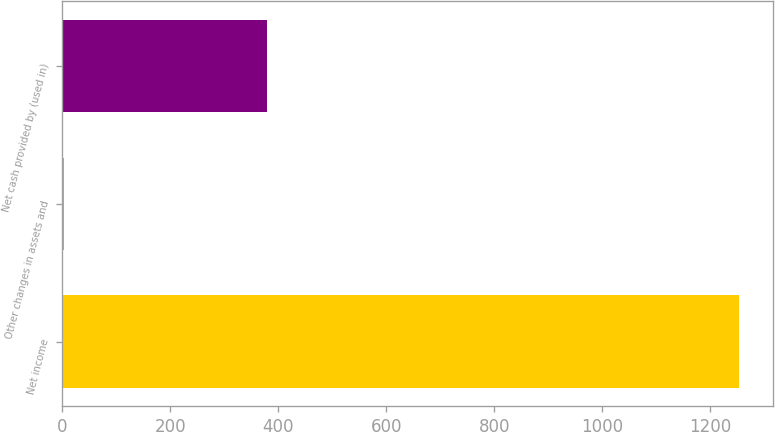Convert chart to OTSL. <chart><loc_0><loc_0><loc_500><loc_500><bar_chart><fcel>Net income<fcel>Other changes in assets and<fcel>Net cash provided by (used in)<nl><fcel>1254<fcel>3.4<fcel>378.58<nl></chart> 